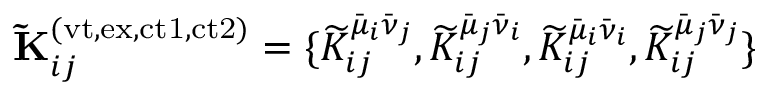Convert formula to latex. <formula><loc_0><loc_0><loc_500><loc_500>\widetilde { K } _ { i j } ^ { ( v t , e x , c t 1 , c t 2 ) } = \{ \widetilde { K } _ { i j } ^ { \bar { \mu } _ { i } \bar { \nu } _ { j } } , \widetilde { K } _ { i j } ^ { \bar { \mu } _ { j } \bar { \nu } _ { i } } , \widetilde { K } _ { i j } ^ { \bar { \mu } _ { i } \bar { \nu } _ { i } } , \widetilde { K } _ { i j } ^ { \bar { \mu } _ { j } \bar { \nu } _ { j } } \}</formula> 